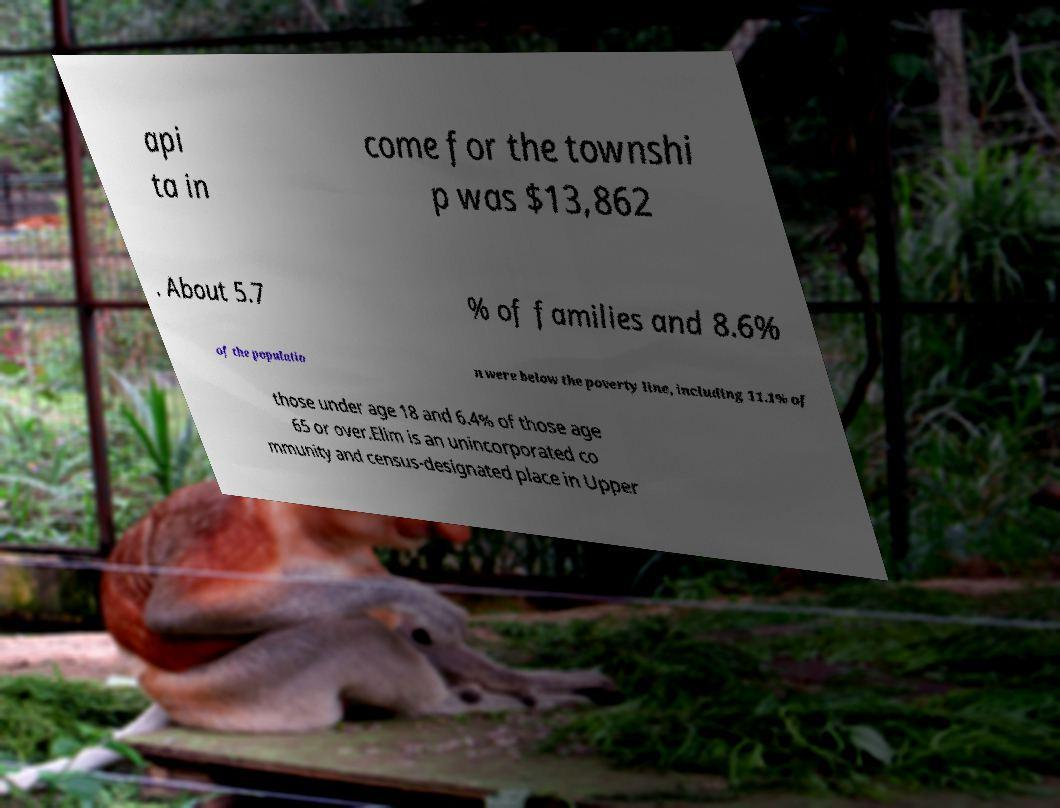I need the written content from this picture converted into text. Can you do that? api ta in come for the townshi p was $13,862 . About 5.7 % of families and 8.6% of the populatio n were below the poverty line, including 11.1% of those under age 18 and 6.4% of those age 65 or over.Elim is an unincorporated co mmunity and census-designated place in Upper 